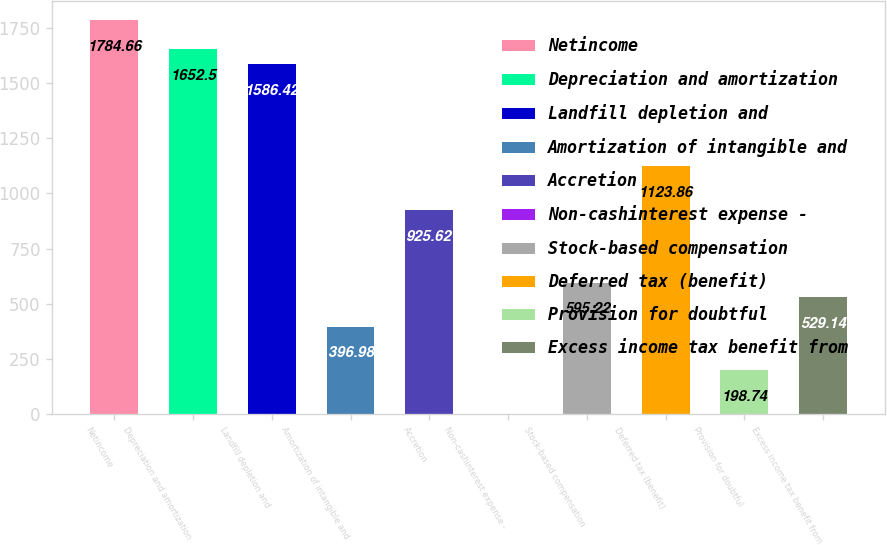Convert chart to OTSL. <chart><loc_0><loc_0><loc_500><loc_500><bar_chart><fcel>Netincome<fcel>Depreciation and amortization<fcel>Landfill depletion and<fcel>Amortization of intangible and<fcel>Accretion<fcel>Non-cashinterest expense -<fcel>Stock-based compensation<fcel>Deferred tax (benefit)<fcel>Provision for doubtful<fcel>Excess income tax benefit from<nl><fcel>1784.66<fcel>1652.5<fcel>1586.42<fcel>396.98<fcel>925.62<fcel>0.5<fcel>595.22<fcel>1123.86<fcel>198.74<fcel>529.14<nl></chart> 